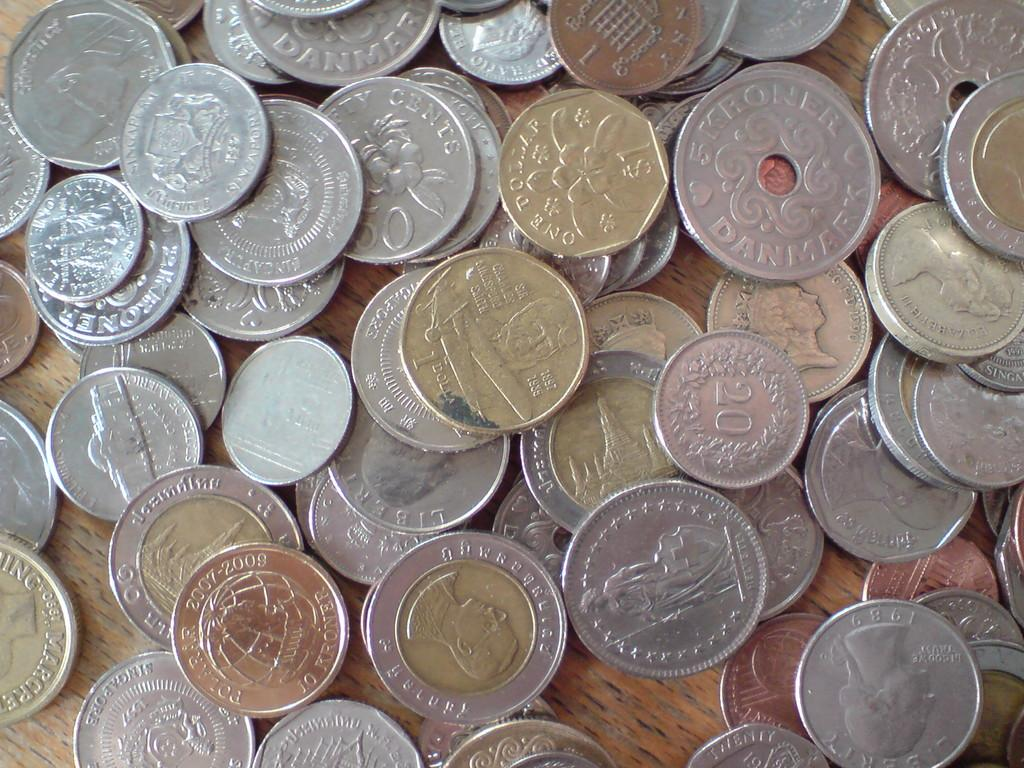<image>
Give a short and clear explanation of the subsequent image. A collection of scattered coins contains American quarters and Danish Kroner, among other coins. 